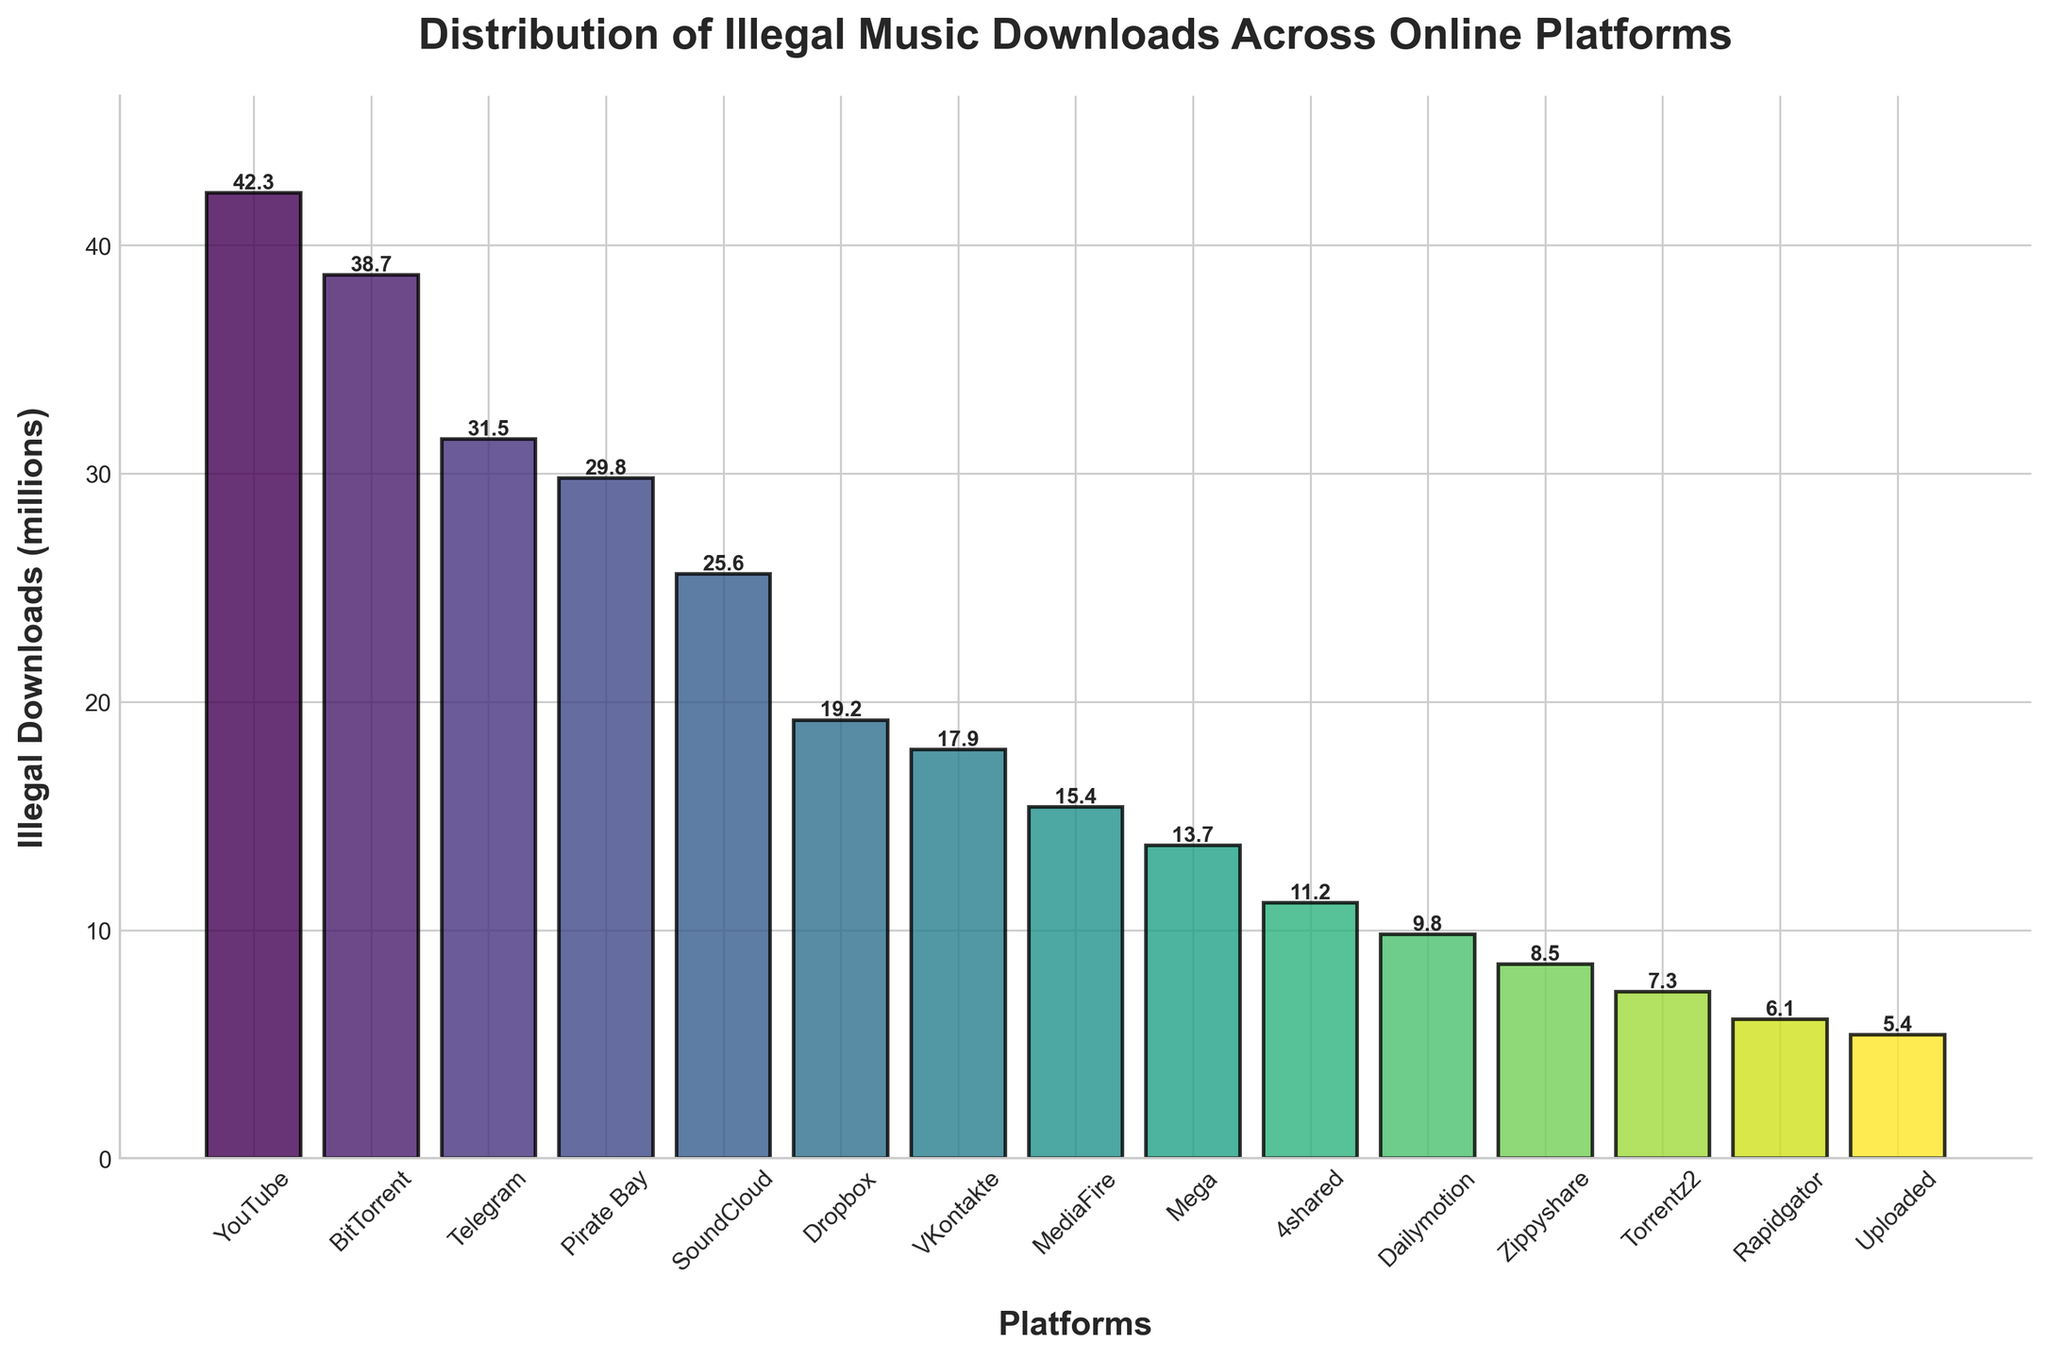Which platform has the highest number of illegal downloads? Observe the heights of the bars. The tallest bar corresponds to YouTube with 42.3 million illegal downloads.
Answer: YouTube Which platform has the lowest number of illegal downloads? Find the shortest bar. The shortest one corresponds to Uploaded with 5.4 million illegal downloads.
Answer: Uploaded How many platforms have more than 20 million illegal downloads? Count the bars that surpass the 20 million mark. YouTube, BitTorrent, Telegram, Pirate Bay, and SoundCloud are the platforms meeting this criterion.
Answer: 5 What is the total number of illegal downloads for the top three platforms combined? Add the heights of the bars for YouTube (42.3), BitTorrent (38.7), and Telegram (31.5): 42.3 + 38.7 + 31.5 = 112.5 million.
Answer: 112.5 million Which platform has approximately half the number of illegal downloads compared to the platform with the highest downloads? Determine the platform with the highest number of illegal downloads (YouTube with 42.3 million). Next, half of 42.3 is 21.15, which is approximately the number for Dropbox with 19.2 million illegal downloads.
Answer: Dropbox What is the difference in illegal downloads between Pirate Bay and SoundCloud? Subtract the illegal downloads of SoundCloud (25.6) from Pirate Bay (29.8): 29.8 - 25.6 = 4.2 million.
Answer: 4.2 million Compare the number of illegal downloads on VKontakte and MediaFire. Which one is higher? Observe the height of the bars for VKontakte (17.9) and MediaFire (15.4). VKontakte has a higher number of illegal downloads.
Answer: VKontakte Is the number of illegal downloads on Zippyshare greater than on Rapidgator? Compare the heights of the bars for Zippyshare (8.5) and Rapidgator (6.1). Zippyshare has more illegal downloads.
Answer: Yes What is the average number of illegal downloads for Mega, 4shared, and Dailymotion? Calculate the average: (Mega 13.7 + 4shared 11.2 + Dailymotion 9.8) / 3 = 34.7 / 3 ≈ 11.57 million.
Answer: 11.57 million Which platform has about one-third the illegal downloads compared to BitTorrent? Find BitTorrent's downloads (38.7) and divide by 3 to get approximately 12.9 million. 4shared has 11.2 million, which is close to one-third of BitTorrent's number.
Answer: 4shared 